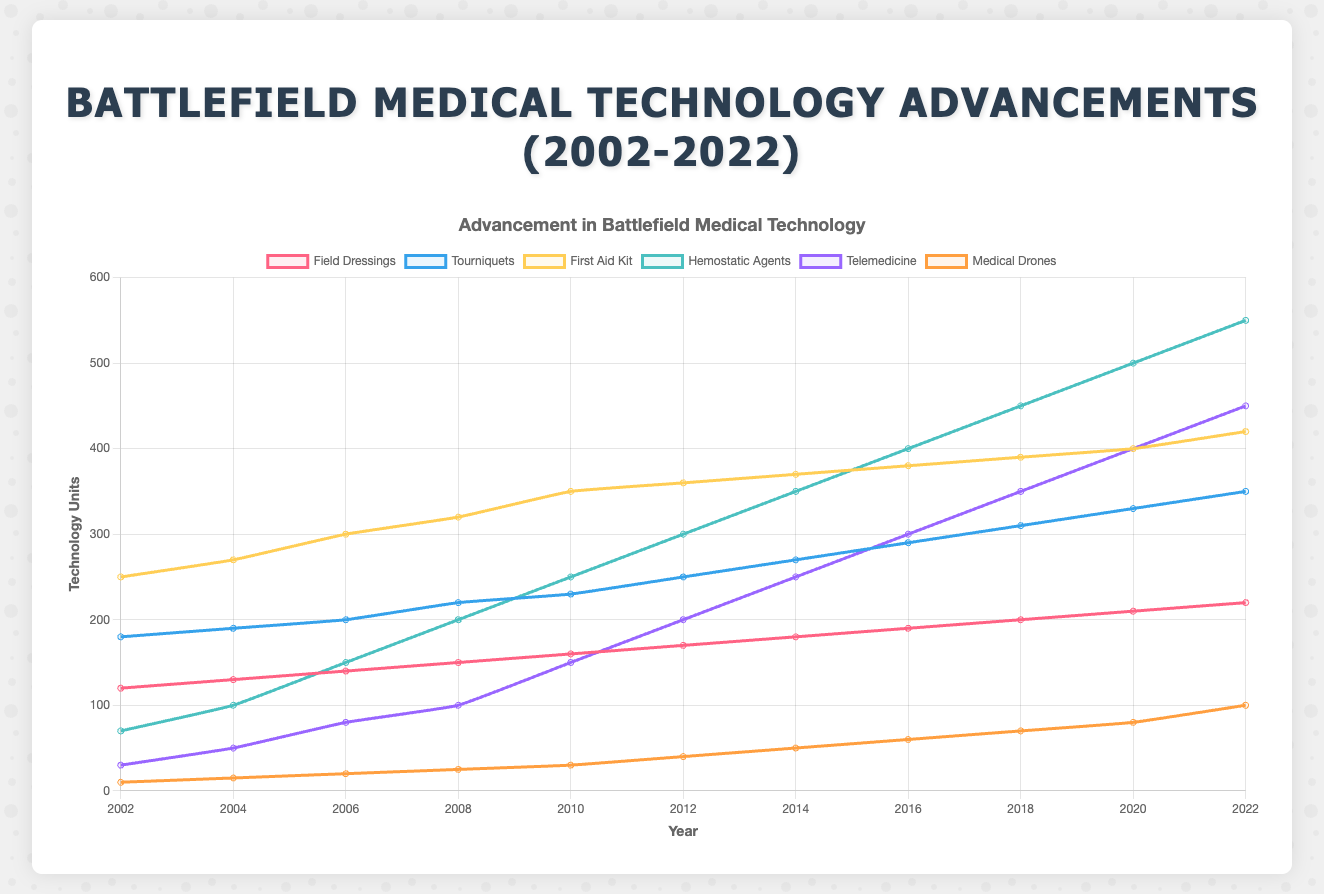What is the trend of Telemedicine units from 2002 to 2022? The Telemedicine units show a steady increase over the years. Starting at 30 units in 2002 and rising gradually to 450 units by 2022.
Answer: Increasing In which year did Hemostatic Agents first exceed 300 units? According to the data, Hemostatic Agents exceeded 300 units for the first time in 2012, reaching 300 units exactly and then continuing to increase.
Answer: 2012 Which medical technology had the least number of units in 2006? In 2006, Medical Drones had the least number of units, with 20 units.
Answer: Medical Drones Compare the number of First Aid Kit units in 2010 and 2012. Which year had more units and by how much? In 2010, there were 350 units of First Aid Kit, whereas in 2012, there were 360 units. This means 2012 had 10 more units than 2010.
Answer: 2012 by 10 units Between 2018 and 2022, which medical technology showed the highest increase in units? Between 2018 and 2022, Hemostatic Agents had the highest increase in units, going from 450 to 550, an increase of 100 units.
Answer: Hemostatic Agents What is the average number of Tourniquets units between 2012 and 2016? The Tourniquets units in 2012, 2014, and 2016 are 250, 270, and 290 respectively. The average is (250 + 270 + 290) / 3 = 810 / 3 = 270 units.
Answer: 270 units Which medical technology showed the sharpest increase from 2016 to 2018? From 2016 to 2018, Hemostatic Agents increased significantly from 400 to 450 units, showing an increase of 50 units, the sharpest among the technologies.
Answer: Hemostatic Agents In 2020, how many more Field Dressings units were there compared to Medical Drones? In 2020, there were 210 Field Dressings units and 80 Medical Drones units. The difference is 210 - 80 = 130 units.
Answer: 130 units What color line represents Tourniquets, and how can you distinguish it visually in the chart? The Tourniquets are represented by a blue line. It is distinguishable visually by its distinct color and follows a fairly consistent upward trend over the years.
Answer: Blue What is the combined number of units for Field Dressings and Tourniquets in 2022? In 2022, Field Dressings had 220 units and Tourniquets had 350 units. Combined, this gives 220 + 350 = 570 units.
Answer: 570 units 